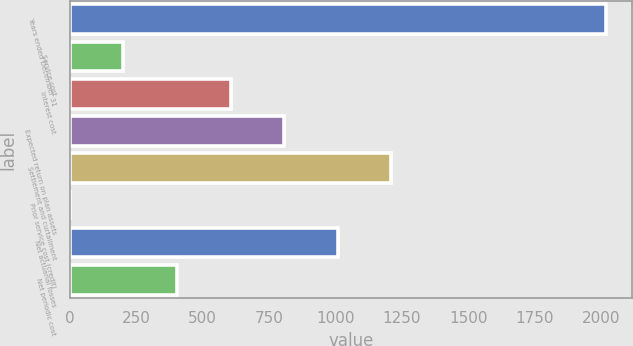Convert chart. <chart><loc_0><loc_0><loc_500><loc_500><bar_chart><fcel>Years ended December 31<fcel>Service cost<fcel>Interest cost<fcel>Expected return on plan assets<fcel>Settlement and curtailment<fcel>Prior service cost (credit)<fcel>Net actuarial losses<fcel>Net periodic cost<nl><fcel>2017<fcel>201.88<fcel>605.24<fcel>806.92<fcel>1210.28<fcel>0.2<fcel>1008.6<fcel>403.56<nl></chart> 